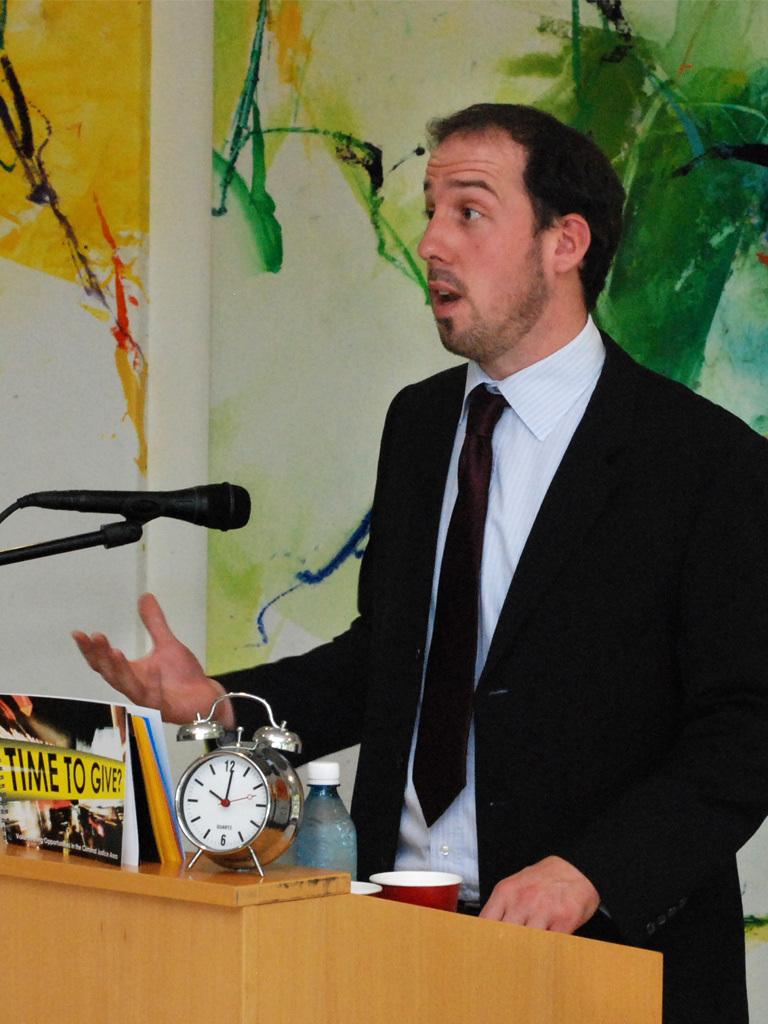What can you give based on the banner?
Make the answer very short. Time. What time is it?
Provide a short and direct response. 10:01. 